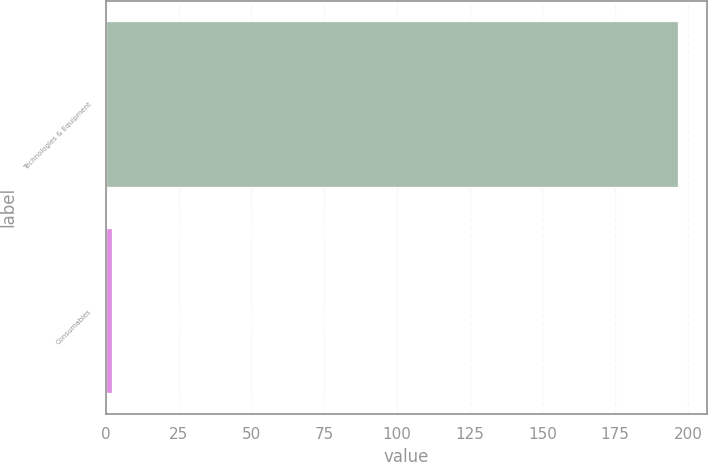Convert chart to OTSL. <chart><loc_0><loc_0><loc_500><loc_500><bar_chart><fcel>Technologies & Equipment<fcel>Consumables<nl><fcel>196.6<fcel>2.1<nl></chart> 